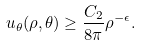Convert formula to latex. <formula><loc_0><loc_0><loc_500><loc_500>u _ { \theta } ( \rho , \theta ) \geq \frac { C _ { 2 } } { 8 \pi } \rho ^ { - \epsilon } .</formula> 